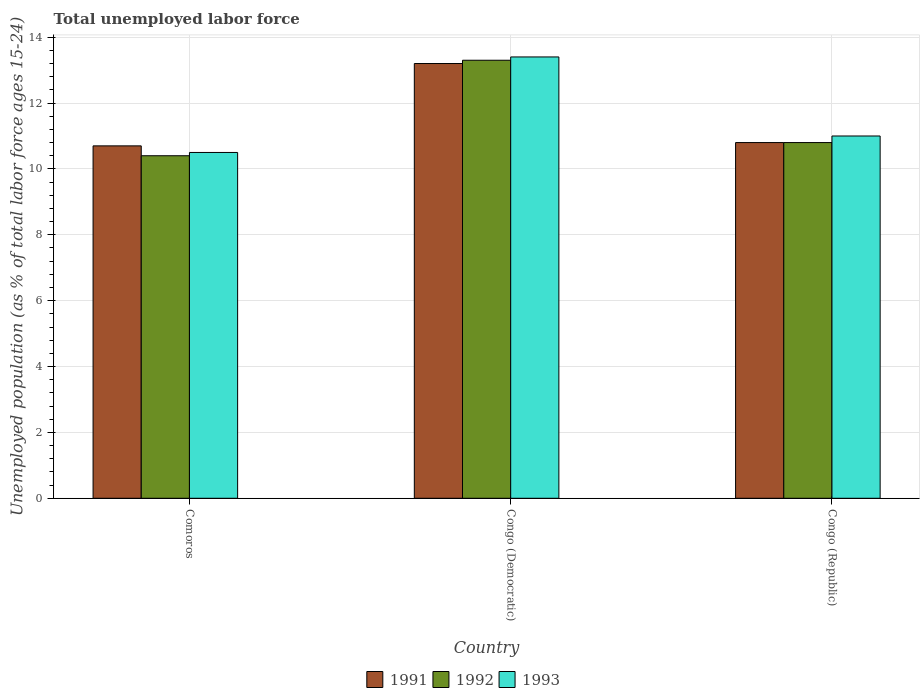How many different coloured bars are there?
Offer a terse response. 3. Are the number of bars per tick equal to the number of legend labels?
Offer a terse response. Yes. How many bars are there on the 2nd tick from the right?
Offer a very short reply. 3. What is the label of the 1st group of bars from the left?
Offer a very short reply. Comoros. In how many cases, is the number of bars for a given country not equal to the number of legend labels?
Your response must be concise. 0. What is the percentage of unemployed population in in 1992 in Congo (Democratic)?
Your answer should be compact. 13.3. Across all countries, what is the maximum percentage of unemployed population in in 1991?
Your answer should be very brief. 13.2. In which country was the percentage of unemployed population in in 1991 maximum?
Your response must be concise. Congo (Democratic). In which country was the percentage of unemployed population in in 1993 minimum?
Your response must be concise. Comoros. What is the total percentage of unemployed population in in 1992 in the graph?
Offer a very short reply. 34.5. What is the difference between the percentage of unemployed population in in 1993 in Comoros and that in Congo (Democratic)?
Your response must be concise. -2.9. What is the difference between the percentage of unemployed population in in 1993 in Congo (Republic) and the percentage of unemployed population in in 1992 in Congo (Democratic)?
Keep it short and to the point. -2.3. What is the average percentage of unemployed population in in 1992 per country?
Your response must be concise. 11.5. What is the difference between the percentage of unemployed population in of/in 1992 and percentage of unemployed population in of/in 1993 in Congo (Republic)?
Ensure brevity in your answer.  -0.2. What is the ratio of the percentage of unemployed population in in 1993 in Comoros to that in Congo (Republic)?
Ensure brevity in your answer.  0.95. Is the percentage of unemployed population in in 1992 in Comoros less than that in Congo (Democratic)?
Offer a terse response. Yes. What is the difference between the highest and the second highest percentage of unemployed population in in 1992?
Give a very brief answer. 0.4. What is the difference between the highest and the lowest percentage of unemployed population in in 1993?
Your answer should be compact. 2.9. Is the sum of the percentage of unemployed population in in 1992 in Congo (Democratic) and Congo (Republic) greater than the maximum percentage of unemployed population in in 1993 across all countries?
Your answer should be very brief. Yes. What does the 2nd bar from the left in Congo (Republic) represents?
Give a very brief answer. 1992. How many bars are there?
Keep it short and to the point. 9. How many countries are there in the graph?
Keep it short and to the point. 3. Are the values on the major ticks of Y-axis written in scientific E-notation?
Make the answer very short. No. Does the graph contain any zero values?
Your response must be concise. No. Does the graph contain grids?
Your response must be concise. Yes. How many legend labels are there?
Give a very brief answer. 3. How are the legend labels stacked?
Keep it short and to the point. Horizontal. What is the title of the graph?
Ensure brevity in your answer.  Total unemployed labor force. Does "2006" appear as one of the legend labels in the graph?
Give a very brief answer. No. What is the label or title of the X-axis?
Give a very brief answer. Country. What is the label or title of the Y-axis?
Provide a succinct answer. Unemployed population (as % of total labor force ages 15-24). What is the Unemployed population (as % of total labor force ages 15-24) in 1991 in Comoros?
Your response must be concise. 10.7. What is the Unemployed population (as % of total labor force ages 15-24) in 1992 in Comoros?
Offer a terse response. 10.4. What is the Unemployed population (as % of total labor force ages 15-24) in 1993 in Comoros?
Offer a terse response. 10.5. What is the Unemployed population (as % of total labor force ages 15-24) of 1991 in Congo (Democratic)?
Make the answer very short. 13.2. What is the Unemployed population (as % of total labor force ages 15-24) of 1992 in Congo (Democratic)?
Provide a succinct answer. 13.3. What is the Unemployed population (as % of total labor force ages 15-24) of 1993 in Congo (Democratic)?
Your answer should be very brief. 13.4. What is the Unemployed population (as % of total labor force ages 15-24) of 1991 in Congo (Republic)?
Ensure brevity in your answer.  10.8. What is the Unemployed population (as % of total labor force ages 15-24) in 1992 in Congo (Republic)?
Keep it short and to the point. 10.8. What is the Unemployed population (as % of total labor force ages 15-24) in 1993 in Congo (Republic)?
Your answer should be very brief. 11. Across all countries, what is the maximum Unemployed population (as % of total labor force ages 15-24) in 1991?
Your response must be concise. 13.2. Across all countries, what is the maximum Unemployed population (as % of total labor force ages 15-24) of 1992?
Your answer should be very brief. 13.3. Across all countries, what is the maximum Unemployed population (as % of total labor force ages 15-24) in 1993?
Keep it short and to the point. 13.4. Across all countries, what is the minimum Unemployed population (as % of total labor force ages 15-24) in 1991?
Make the answer very short. 10.7. Across all countries, what is the minimum Unemployed population (as % of total labor force ages 15-24) in 1992?
Offer a very short reply. 10.4. What is the total Unemployed population (as % of total labor force ages 15-24) of 1991 in the graph?
Offer a terse response. 34.7. What is the total Unemployed population (as % of total labor force ages 15-24) in 1992 in the graph?
Your answer should be compact. 34.5. What is the total Unemployed population (as % of total labor force ages 15-24) in 1993 in the graph?
Offer a terse response. 34.9. What is the difference between the Unemployed population (as % of total labor force ages 15-24) of 1991 in Comoros and that in Congo (Democratic)?
Give a very brief answer. -2.5. What is the difference between the Unemployed population (as % of total labor force ages 15-24) of 1992 in Comoros and that in Congo (Democratic)?
Offer a very short reply. -2.9. What is the difference between the Unemployed population (as % of total labor force ages 15-24) of 1991 in Comoros and that in Congo (Republic)?
Provide a succinct answer. -0.1. What is the difference between the Unemployed population (as % of total labor force ages 15-24) of 1992 in Comoros and that in Congo (Republic)?
Your answer should be compact. -0.4. What is the difference between the Unemployed population (as % of total labor force ages 15-24) in 1993 in Comoros and that in Congo (Republic)?
Provide a short and direct response. -0.5. What is the difference between the Unemployed population (as % of total labor force ages 15-24) in 1991 in Congo (Democratic) and that in Congo (Republic)?
Your response must be concise. 2.4. What is the difference between the Unemployed population (as % of total labor force ages 15-24) in 1991 in Comoros and the Unemployed population (as % of total labor force ages 15-24) in 1993 in Congo (Democratic)?
Give a very brief answer. -2.7. What is the difference between the Unemployed population (as % of total labor force ages 15-24) of 1992 in Comoros and the Unemployed population (as % of total labor force ages 15-24) of 1993 in Congo (Democratic)?
Provide a succinct answer. -3. What is the difference between the Unemployed population (as % of total labor force ages 15-24) of 1991 in Comoros and the Unemployed population (as % of total labor force ages 15-24) of 1993 in Congo (Republic)?
Give a very brief answer. -0.3. What is the difference between the Unemployed population (as % of total labor force ages 15-24) in 1991 in Congo (Democratic) and the Unemployed population (as % of total labor force ages 15-24) in 1992 in Congo (Republic)?
Make the answer very short. 2.4. What is the difference between the Unemployed population (as % of total labor force ages 15-24) in 1991 in Congo (Democratic) and the Unemployed population (as % of total labor force ages 15-24) in 1993 in Congo (Republic)?
Your answer should be compact. 2.2. What is the average Unemployed population (as % of total labor force ages 15-24) of 1991 per country?
Your answer should be compact. 11.57. What is the average Unemployed population (as % of total labor force ages 15-24) in 1993 per country?
Ensure brevity in your answer.  11.63. What is the difference between the Unemployed population (as % of total labor force ages 15-24) in 1991 and Unemployed population (as % of total labor force ages 15-24) in 1992 in Comoros?
Your response must be concise. 0.3. What is the difference between the Unemployed population (as % of total labor force ages 15-24) of 1992 and Unemployed population (as % of total labor force ages 15-24) of 1993 in Comoros?
Give a very brief answer. -0.1. What is the difference between the Unemployed population (as % of total labor force ages 15-24) in 1991 and Unemployed population (as % of total labor force ages 15-24) in 1992 in Congo (Democratic)?
Your response must be concise. -0.1. What is the difference between the Unemployed population (as % of total labor force ages 15-24) in 1991 and Unemployed population (as % of total labor force ages 15-24) in 1993 in Congo (Democratic)?
Provide a succinct answer. -0.2. What is the difference between the Unemployed population (as % of total labor force ages 15-24) in 1991 and Unemployed population (as % of total labor force ages 15-24) in 1992 in Congo (Republic)?
Your response must be concise. 0. What is the difference between the Unemployed population (as % of total labor force ages 15-24) of 1992 and Unemployed population (as % of total labor force ages 15-24) of 1993 in Congo (Republic)?
Your response must be concise. -0.2. What is the ratio of the Unemployed population (as % of total labor force ages 15-24) in 1991 in Comoros to that in Congo (Democratic)?
Give a very brief answer. 0.81. What is the ratio of the Unemployed population (as % of total labor force ages 15-24) of 1992 in Comoros to that in Congo (Democratic)?
Provide a succinct answer. 0.78. What is the ratio of the Unemployed population (as % of total labor force ages 15-24) in 1993 in Comoros to that in Congo (Democratic)?
Your answer should be compact. 0.78. What is the ratio of the Unemployed population (as % of total labor force ages 15-24) in 1993 in Comoros to that in Congo (Republic)?
Ensure brevity in your answer.  0.95. What is the ratio of the Unemployed population (as % of total labor force ages 15-24) of 1991 in Congo (Democratic) to that in Congo (Republic)?
Offer a terse response. 1.22. What is the ratio of the Unemployed population (as % of total labor force ages 15-24) of 1992 in Congo (Democratic) to that in Congo (Republic)?
Your answer should be very brief. 1.23. What is the ratio of the Unemployed population (as % of total labor force ages 15-24) in 1993 in Congo (Democratic) to that in Congo (Republic)?
Keep it short and to the point. 1.22. What is the difference between the highest and the second highest Unemployed population (as % of total labor force ages 15-24) of 1991?
Keep it short and to the point. 2.4. What is the difference between the highest and the second highest Unemployed population (as % of total labor force ages 15-24) in 1992?
Your answer should be very brief. 2.5. What is the difference between the highest and the lowest Unemployed population (as % of total labor force ages 15-24) of 1991?
Give a very brief answer. 2.5. What is the difference between the highest and the lowest Unemployed population (as % of total labor force ages 15-24) of 1992?
Keep it short and to the point. 2.9. What is the difference between the highest and the lowest Unemployed population (as % of total labor force ages 15-24) of 1993?
Provide a succinct answer. 2.9. 